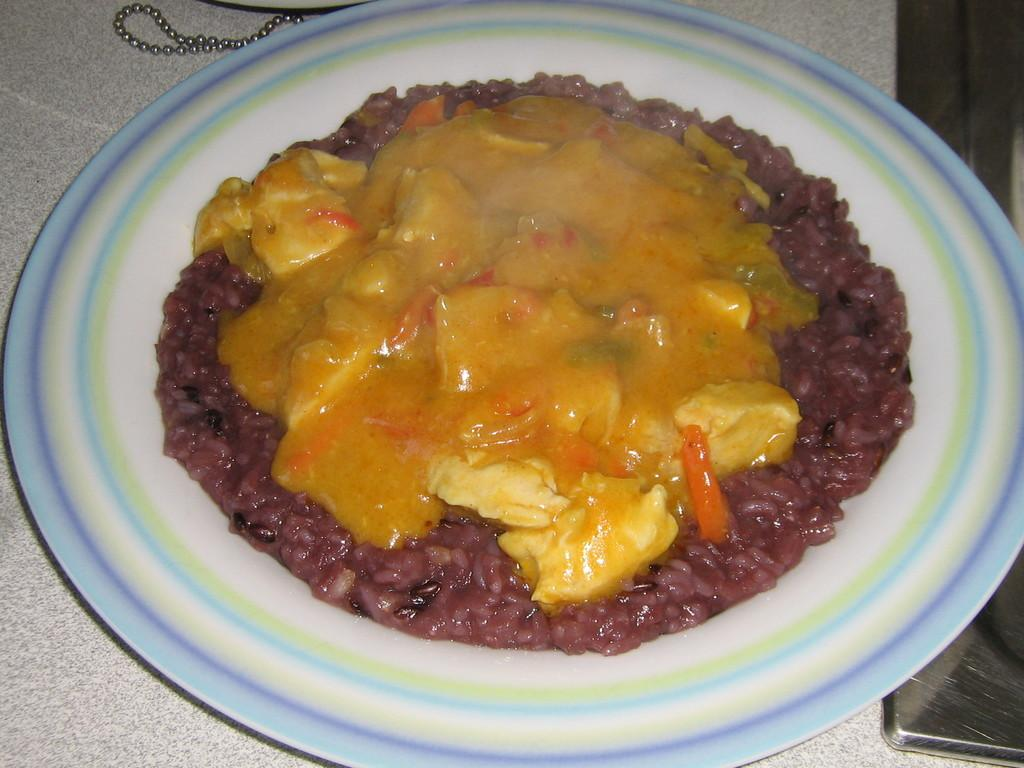What is the main subject of the image? There is a cooked food item in the image. How is the food item presented in the image? The food item is served on a plate. What is the monetary value of the meat on the plate in the image? There is no mention of meat in the image, and the value of the food item cannot be determined from the image alone. 